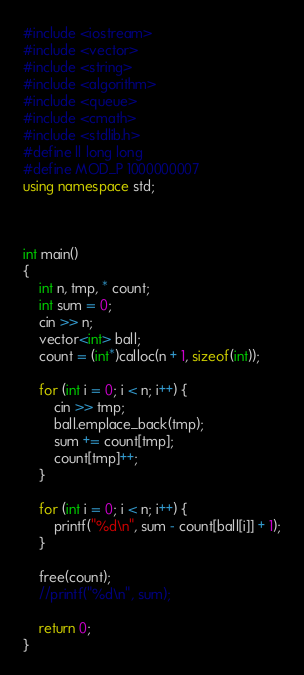<code> <loc_0><loc_0><loc_500><loc_500><_C++_>#include <iostream>
#include <vector>
#include <string>
#include <algorithm>
#include <queue>
#include <cmath>
#include <stdlib.h>
#define ll long long
#define MOD_P 1000000007
using namespace std;



int main()
{
	int n, tmp, * count;
	int sum = 0;
	cin >> n;
	vector<int> ball;
	count = (int*)calloc(n + 1, sizeof(int));

	for (int i = 0; i < n; i++) {
		cin >> tmp;
		ball.emplace_back(tmp);
		sum += count[tmp];
		count[tmp]++;
	}

	for (int i = 0; i < n; i++) {
		printf("%d\n", sum - count[ball[i]] + 1);
	}

	free(count);
	//printf("%d\n", sum);

	return 0;
}</code> 